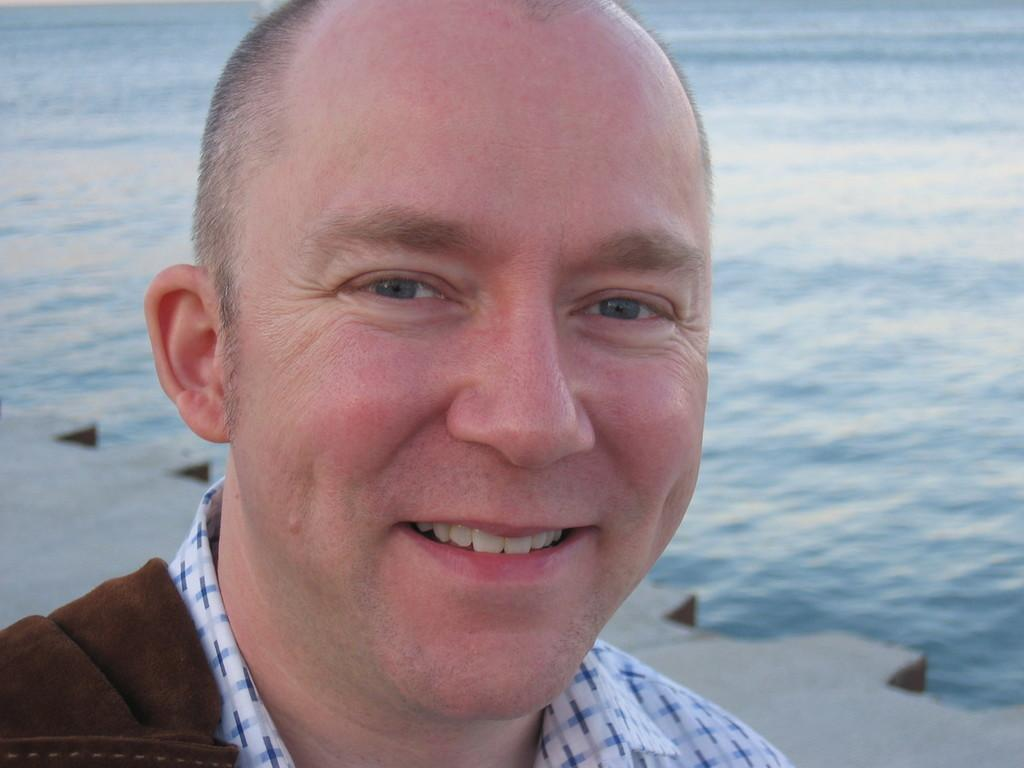Who is present in the image? There is a man in the image. What is the man's facial expression? The man is smiling. What can be seen in the distance in the image? There is a lake visible in the background of the image. What type of tiger design can be seen on the man's shirt in the image? There is no tiger design visible on the man's shirt in the image. What type of waves can be seen in the lake in the image? There are no waves visible in the lake in the image; it appears to be calm. 